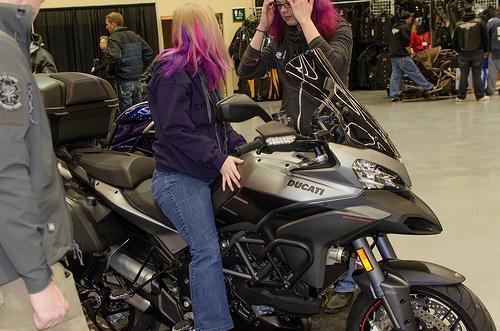How many colors is the girl's hair?
Give a very brief answer. 3. How many new tires are on the motorcycle?
Give a very brief answer. 2. How many people have pink hair?
Give a very brief answer. 2. 